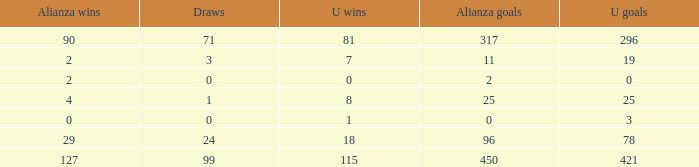What is the complete sum of u wins when alianza goals stands at "0" and u goals is more than 3? 0.0. 